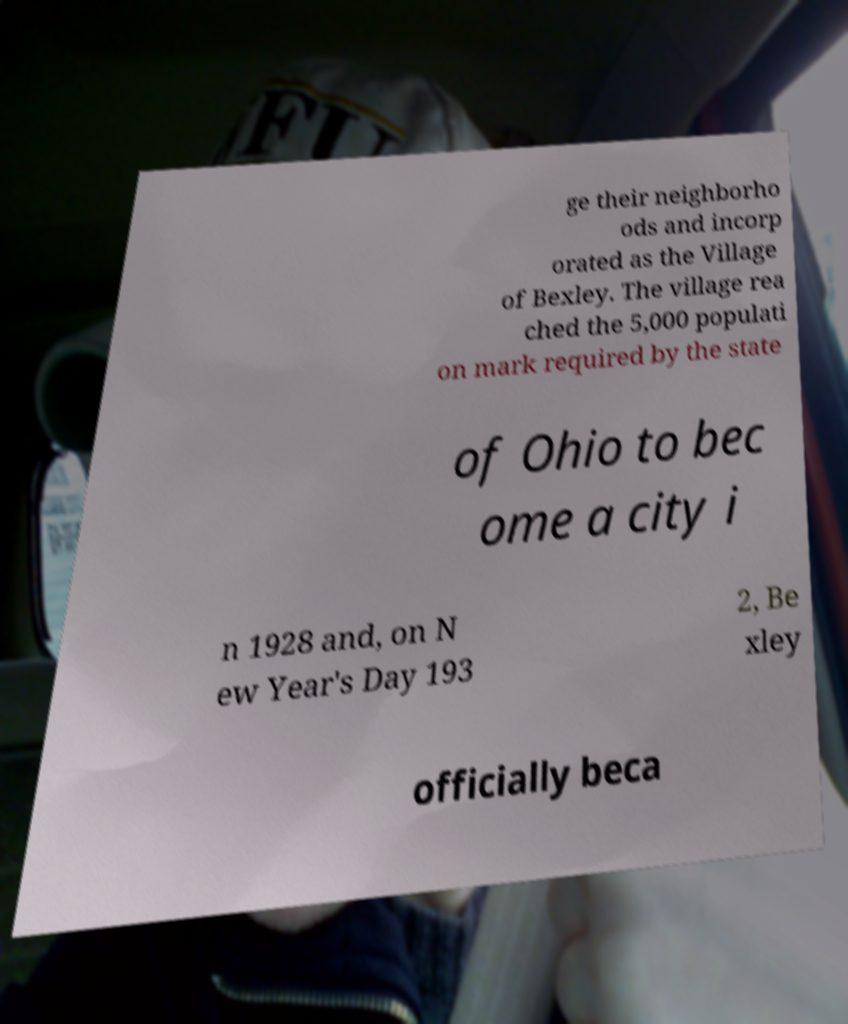Please read and relay the text visible in this image. What does it say? ge their neighborho ods and incorp orated as the Village of Bexley. The village rea ched the 5,000 populati on mark required by the state of Ohio to bec ome a city i n 1928 and, on N ew Year's Day 193 2, Be xley officially beca 